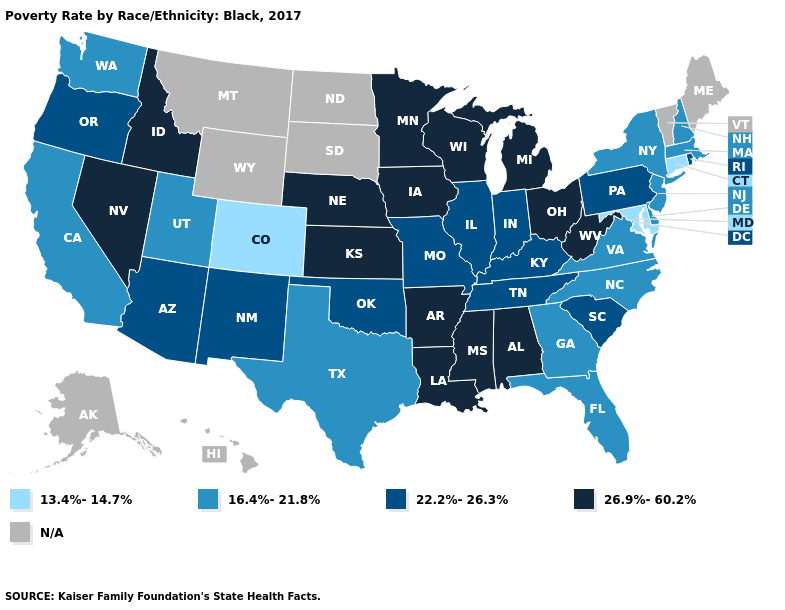Does Minnesota have the highest value in the USA?
Give a very brief answer. Yes. Does Missouri have the lowest value in the USA?
Answer briefly. No. Among the states that border Kansas , which have the highest value?
Answer briefly. Nebraska. Does the map have missing data?
Write a very short answer. Yes. Does New York have the highest value in the Northeast?
Concise answer only. No. What is the highest value in states that border Oklahoma?
Keep it brief. 26.9%-60.2%. What is the highest value in the Northeast ?
Short answer required. 22.2%-26.3%. Among the states that border New York , which have the highest value?
Write a very short answer. Pennsylvania. What is the value of Wyoming?
Keep it brief. N/A. Name the states that have a value in the range 26.9%-60.2%?
Answer briefly. Alabama, Arkansas, Idaho, Iowa, Kansas, Louisiana, Michigan, Minnesota, Mississippi, Nebraska, Nevada, Ohio, West Virginia, Wisconsin. Name the states that have a value in the range 26.9%-60.2%?
Short answer required. Alabama, Arkansas, Idaho, Iowa, Kansas, Louisiana, Michigan, Minnesota, Mississippi, Nebraska, Nevada, Ohio, West Virginia, Wisconsin. What is the value of Delaware?
Answer briefly. 16.4%-21.8%. Name the states that have a value in the range 26.9%-60.2%?
Short answer required. Alabama, Arkansas, Idaho, Iowa, Kansas, Louisiana, Michigan, Minnesota, Mississippi, Nebraska, Nevada, Ohio, West Virginia, Wisconsin. Name the states that have a value in the range N/A?
Quick response, please. Alaska, Hawaii, Maine, Montana, North Dakota, South Dakota, Vermont, Wyoming. 